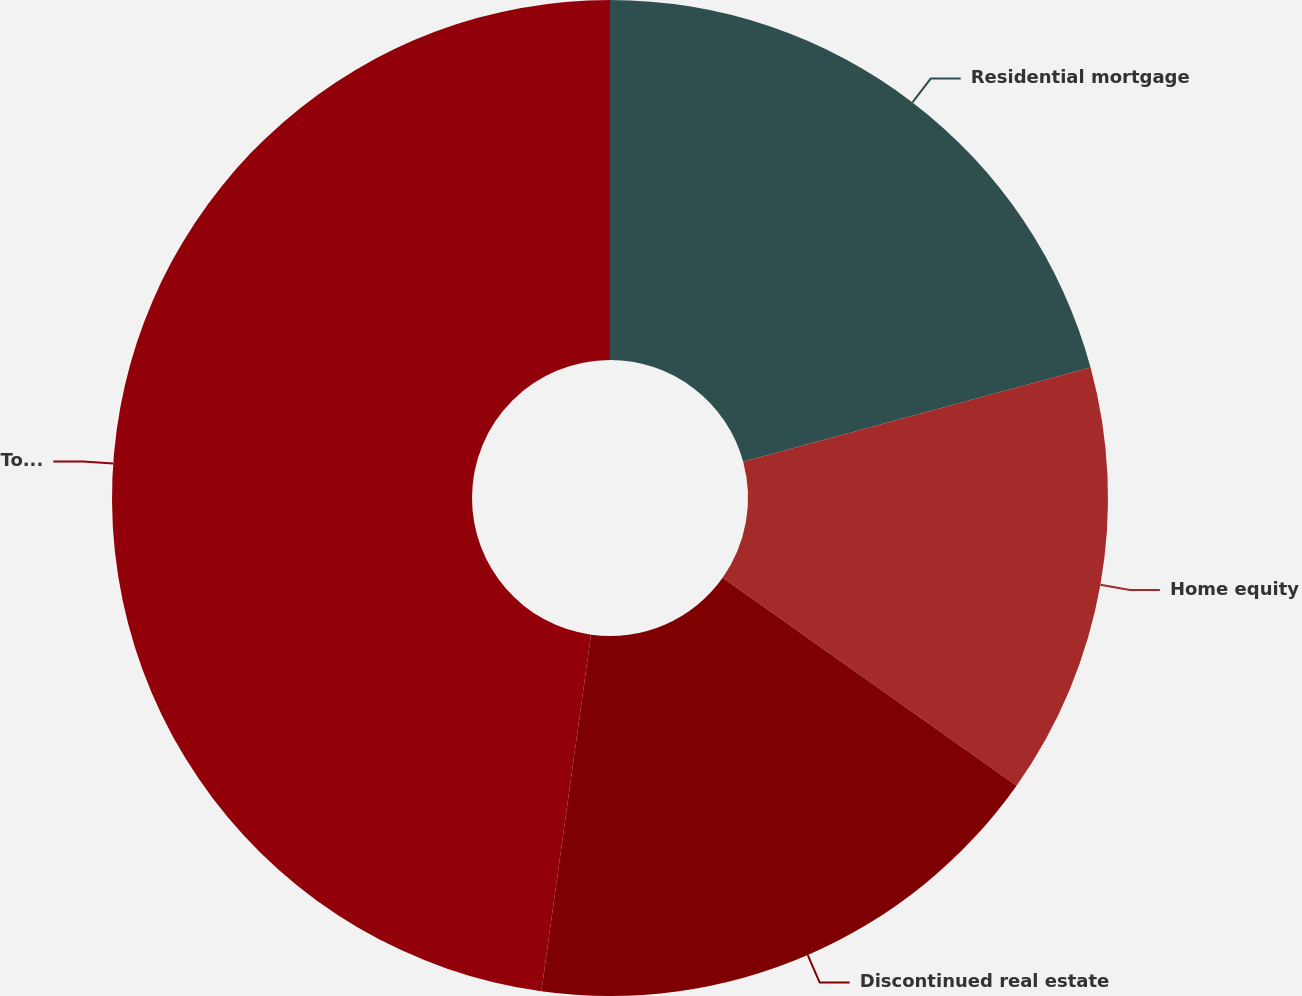Convert chart. <chart><loc_0><loc_0><loc_500><loc_500><pie_chart><fcel>Residential mortgage<fcel>Home equity<fcel>Discontinued real estate<fcel>Total Countrywide purchased<nl><fcel>20.78%<fcel>14.02%<fcel>17.4%<fcel>47.8%<nl></chart> 